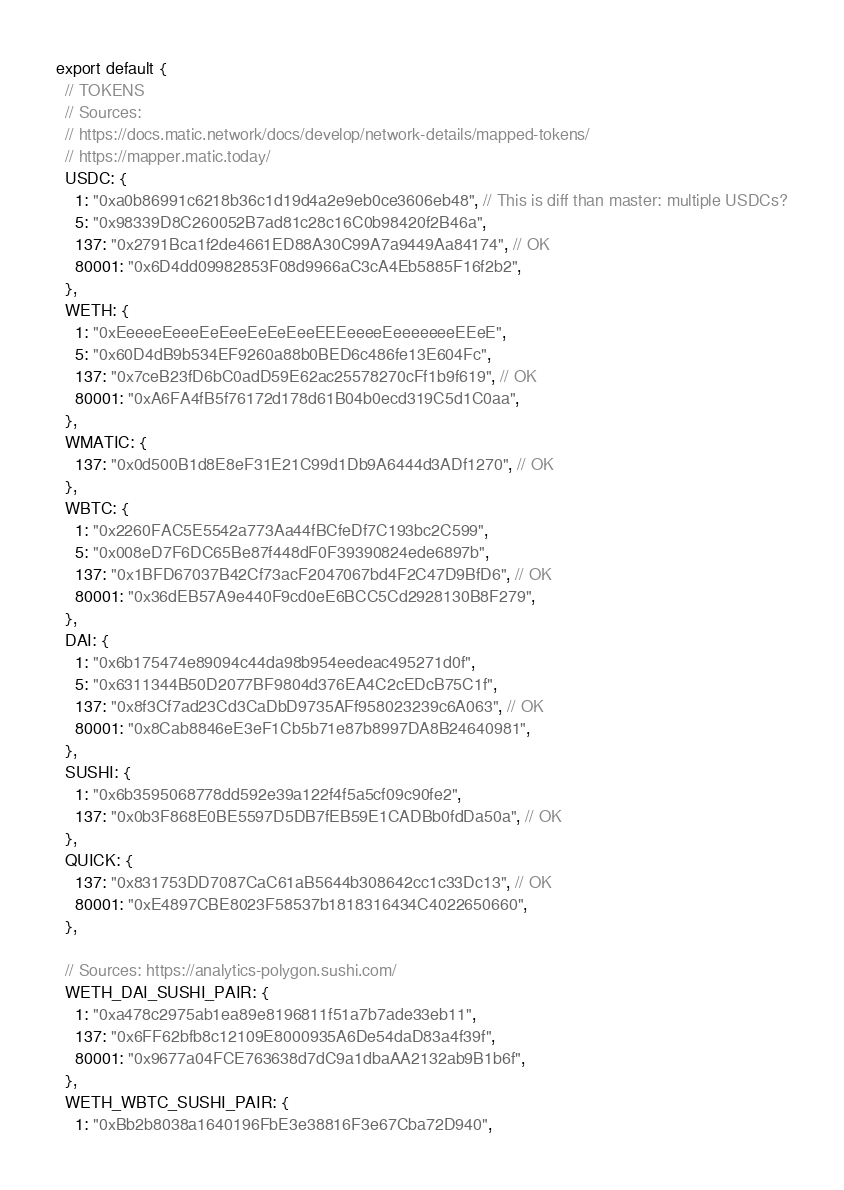Convert code to text. <code><loc_0><loc_0><loc_500><loc_500><_TypeScript_>
export default {
  // TOKENS
  // Sources:
  // https://docs.matic.network/docs/develop/network-details/mapped-tokens/
  // https://mapper.matic.today/
  USDC: {
    1: "0xa0b86991c6218b36c1d19d4a2e9eb0ce3606eb48", // This is diff than master: multiple USDCs?
    5: "0x98339D8C260052B7ad81c28c16C0b98420f2B46a",
    137: "0x2791Bca1f2de4661ED88A30C99A7a9449Aa84174", // OK
    80001: "0x6D4dd09982853F08d9966aC3cA4Eb5885F16f2b2",
  },
  WETH: {
    1: "0xEeeeeEeeeEeEeeEeEeEeeEEEeeeeEeeeeeeeEEeE",
    5: "0x60D4dB9b534EF9260a88b0BED6c486fe13E604Fc",
    137: "0x7ceB23fD6bC0adD59E62ac25578270cFf1b9f619", // OK
    80001: "0xA6FA4fB5f76172d178d61B04b0ecd319C5d1C0aa",
  },
  WMATIC: {
    137: "0x0d500B1d8E8eF31E21C99d1Db9A6444d3ADf1270", // OK
  },
  WBTC: {
    1: "0x2260FAC5E5542a773Aa44fBCfeDf7C193bc2C599",
    5: "0x008eD7F6DC65Be87f448dF0F39390824ede6897b",
    137: "0x1BFD67037B42Cf73acF2047067bd4F2C47D9BfD6", // OK
    80001: "0x36dEB57A9e440F9cd0eE6BCC5Cd2928130B8F279",
  },
  DAI: {
    1: "0x6b175474e89094c44da98b954eedeac495271d0f",
    5: "0x6311344B50D2077BF9804d376EA4C2cEDcB75C1f",
    137: "0x8f3Cf7ad23Cd3CaDbD9735AFf958023239c6A063", // OK
    80001: "0x8Cab8846eE3eF1Cb5b71e87b8997DA8B24640981",
  },
  SUSHI: {
    1: "0x6b3595068778dd592e39a122f4f5a5cf09c90fe2",
    137: "0x0b3F868E0BE5597D5DB7fEB59E1CADBb0fdDa50a", // OK
  },
  QUICK: {
    137: "0x831753DD7087CaC61aB5644b308642cc1c33Dc13", // OK
    80001: "0xE4897CBE8023F58537b1818316434C4022650660",
  },

  // Sources: https://analytics-polygon.sushi.com/
  WETH_DAI_SUSHI_PAIR: {
    1: "0xa478c2975ab1ea89e8196811f51a7b7ade33eb11",
    137: "0x6FF62bfb8c12109E8000935A6De54daD83a4f39f",
    80001: "0x9677a04FCE763638d7dC9a1dbaAA2132ab9B1b6f",
  },
  WETH_WBTC_SUSHI_PAIR: {
    1: "0xBb2b8038a1640196FbE3e38816F3e67Cba72D940",</code> 